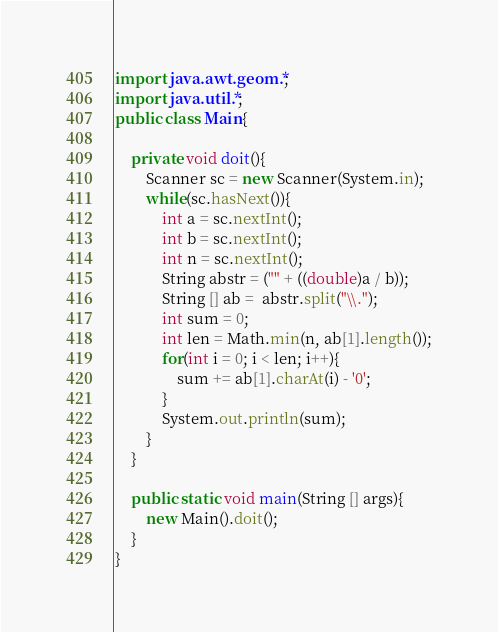<code> <loc_0><loc_0><loc_500><loc_500><_Java_>import java.awt.geom.*;
import java.util.*;
public class Main{
	
	private void doit(){
		Scanner sc = new Scanner(System.in);
		while(sc.hasNext()){
			int a = sc.nextInt();
			int b = sc.nextInt();
			int n = sc.nextInt();
			String abstr = ("" + ((double)a / b));
			String [] ab =  abstr.split("\\.");
			int sum = 0;
			int len = Math.min(n, ab[1].length());
			for(int i = 0; i < len; i++){
				sum += ab[1].charAt(i) - '0';
			}
			System.out.println(sum);
		}
	}
	
	public static void main(String [] args){
		new Main().doit();
	}
}</code> 